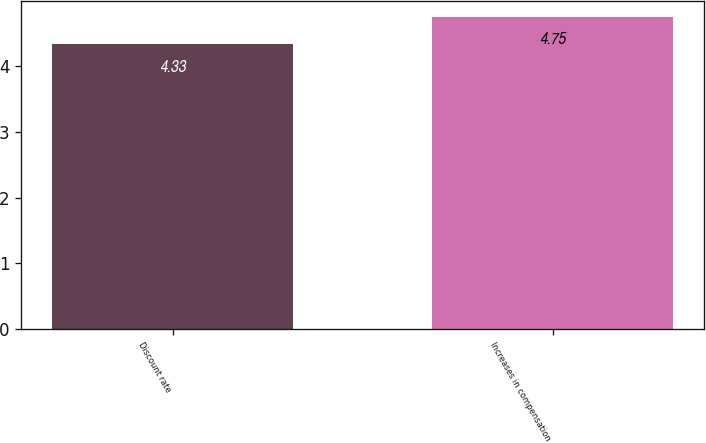<chart> <loc_0><loc_0><loc_500><loc_500><bar_chart><fcel>Discount rate<fcel>Increases in compensation<nl><fcel>4.33<fcel>4.75<nl></chart> 